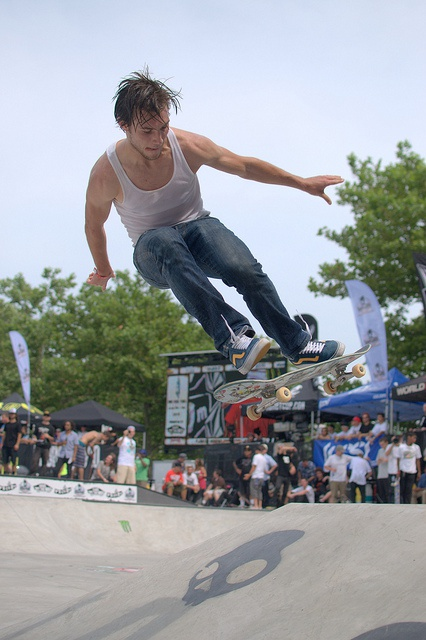Describe the objects in this image and their specific colors. I can see people in lavender, gray, and black tones, people in lavender, black, gray, and darkgray tones, skateboard in lavender and gray tones, people in lavender, black, darkgray, and gray tones, and people in lavender, darkgray, tan, and gray tones in this image. 